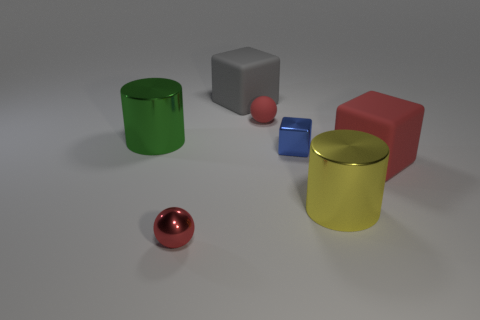Add 1 tiny gray cylinders. How many objects exist? 8 Subtract all cubes. How many objects are left? 4 Subtract 0 purple cylinders. How many objects are left? 7 Subtract all large red metallic cylinders. Subtract all shiny cubes. How many objects are left? 6 Add 7 tiny red objects. How many tiny red objects are left? 9 Add 7 yellow metal cylinders. How many yellow metal cylinders exist? 8 